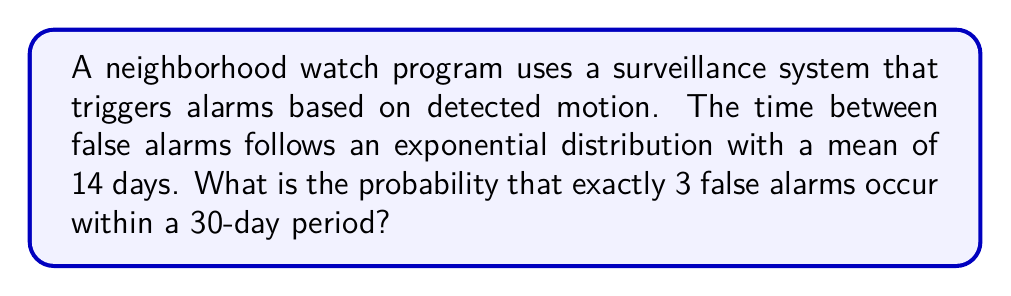Teach me how to tackle this problem. To solve this problem, we'll use the Poisson process, which is a type of renewal process where the interarrival times are exponentially distributed.

Step 1: Identify the rate parameter (λ) of the Poisson process.
The mean time between false alarms is 14 days, so λ = 1/14 alarms per day.

Step 2: Calculate the expected number of false alarms in 30 days.
Let μ be the expected number of false alarms in 30 days.
μ = λ * 30 = (1/14) * 30 ≈ 2.1429

Step 3: Use the Poisson probability mass function to calculate the probability of exactly 3 false alarms in 30 days.
The probability mass function for a Poisson distribution is:

$$ P(X = k) = \frac{e^{-μ} μ^k}{k!} $$

Where:
X is the number of events (false alarms)
k is the specific number we're interested in (3 in this case)
μ is the expected number of events
e is Euler's number (approximately 2.71828)

Substituting our values:

$$ P(X = 3) = \frac{e^{-2.1429} (2.1429)^3}{3!} $$

Step 4: Calculate the result.
$$ P(X = 3) = \frac{e^{-2.1429} (2.1429)^3}{6} $$
$$ P(X = 3) ≈ 0.2044 $$

Therefore, the probability of exactly 3 false alarms occurring within a 30-day period is approximately 0.2044 or 20.44%.
Answer: 0.2044 